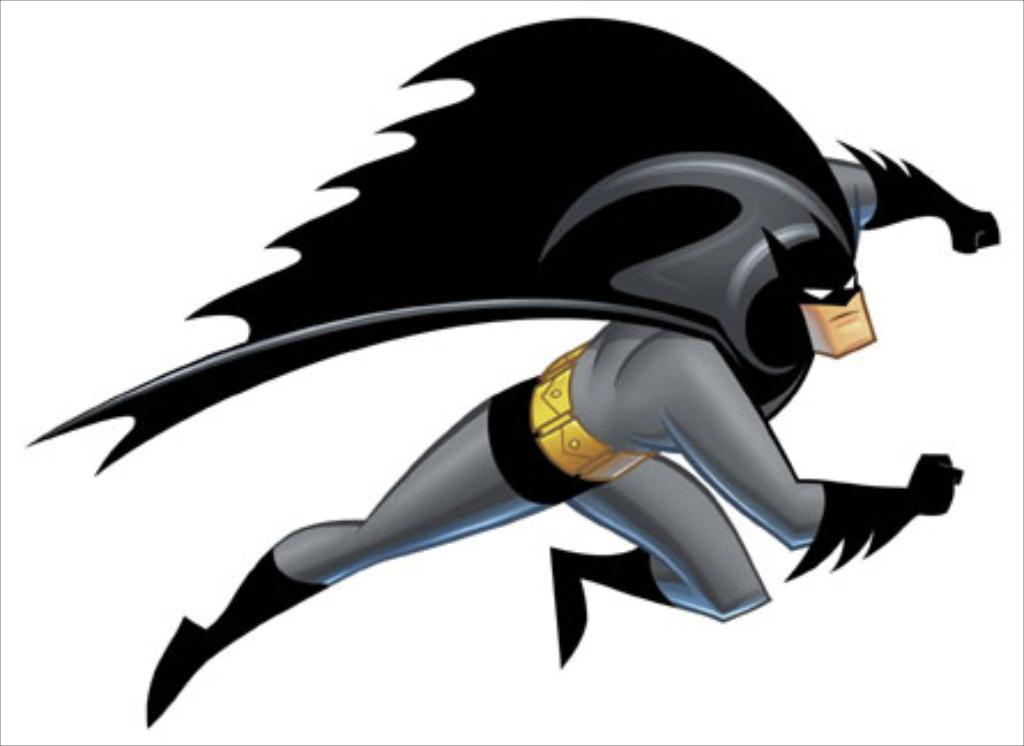What character can be seen in the image? There is a character resembling Batman in the image. What is the character wearing? The character is wearing a black and ash-colored dress. What is the character doing in the image? The character is flying in the air. What type of art is the image? The image is a digital art. How many ants can be seen crawling on the character's dress in the image? There are no ants present in the image; the character is wearing a black and ash-colored dress while flying in the air. What type of appliance is visible in the image? There are no appliances present in the image; it features a character resembling Batman flying in the air. 